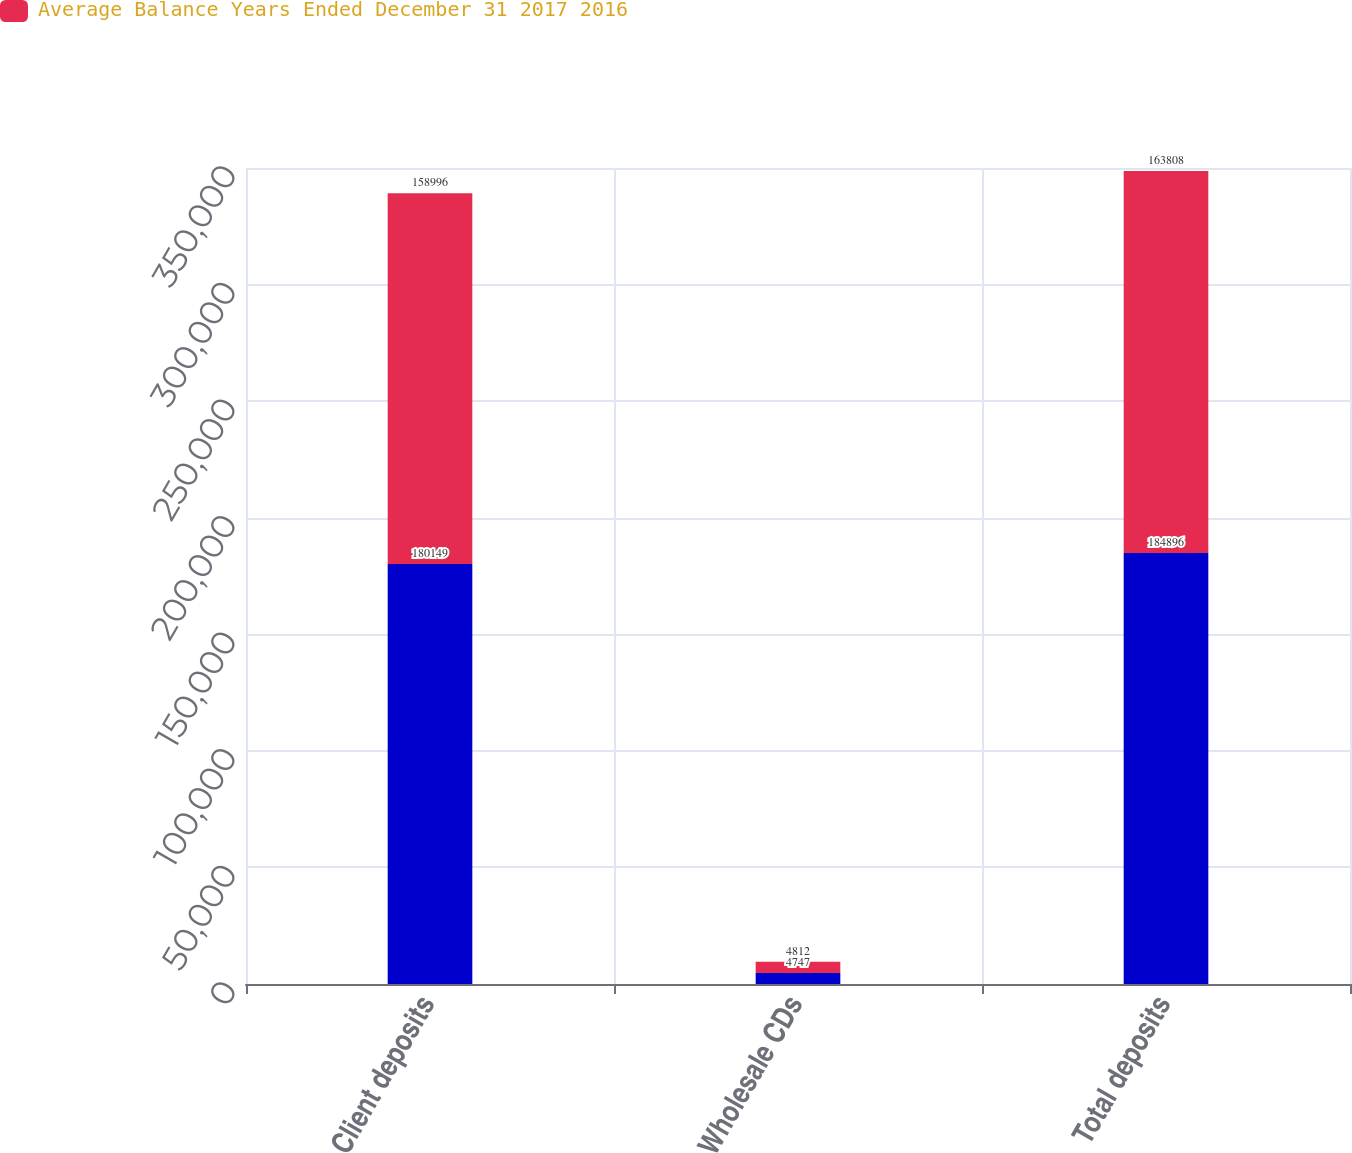<chart> <loc_0><loc_0><loc_500><loc_500><stacked_bar_chart><ecel><fcel>Client deposits<fcel>Wholesale CDs<fcel>Total deposits<nl><fcel>nan<fcel>180149<fcel>4747<fcel>184896<nl><fcel>Average Balance Years Ended December 31 2017 2016<fcel>158996<fcel>4812<fcel>163808<nl></chart> 